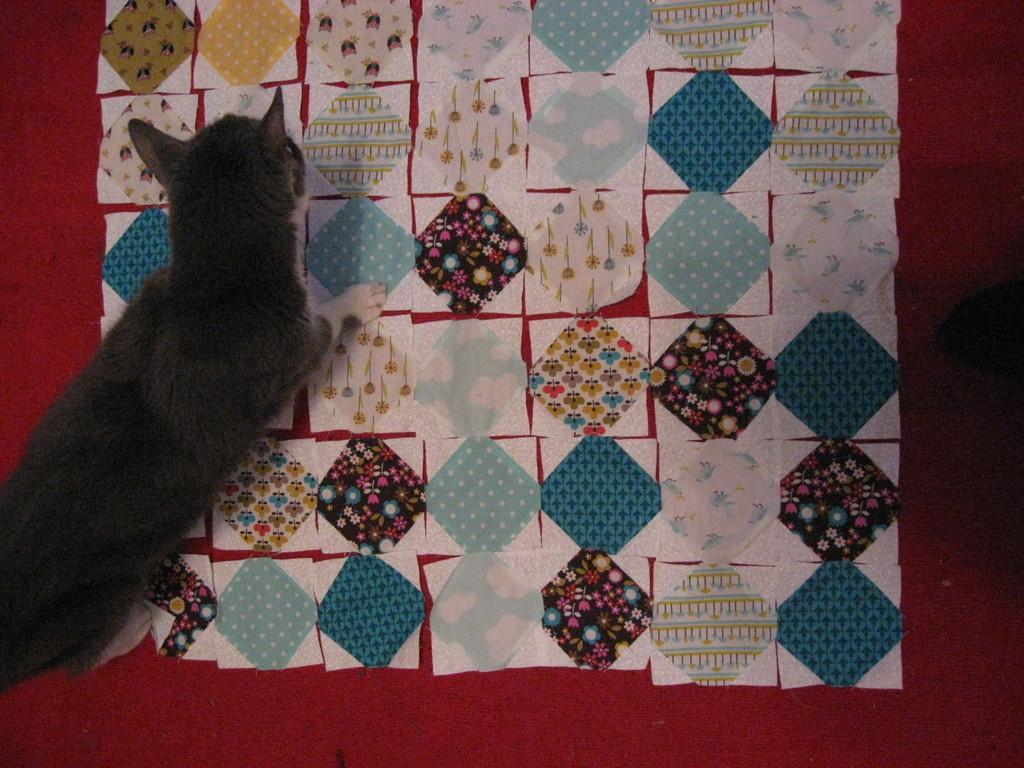Could you give a brief overview of what you see in this image? In this image there is a cat on the mat. 